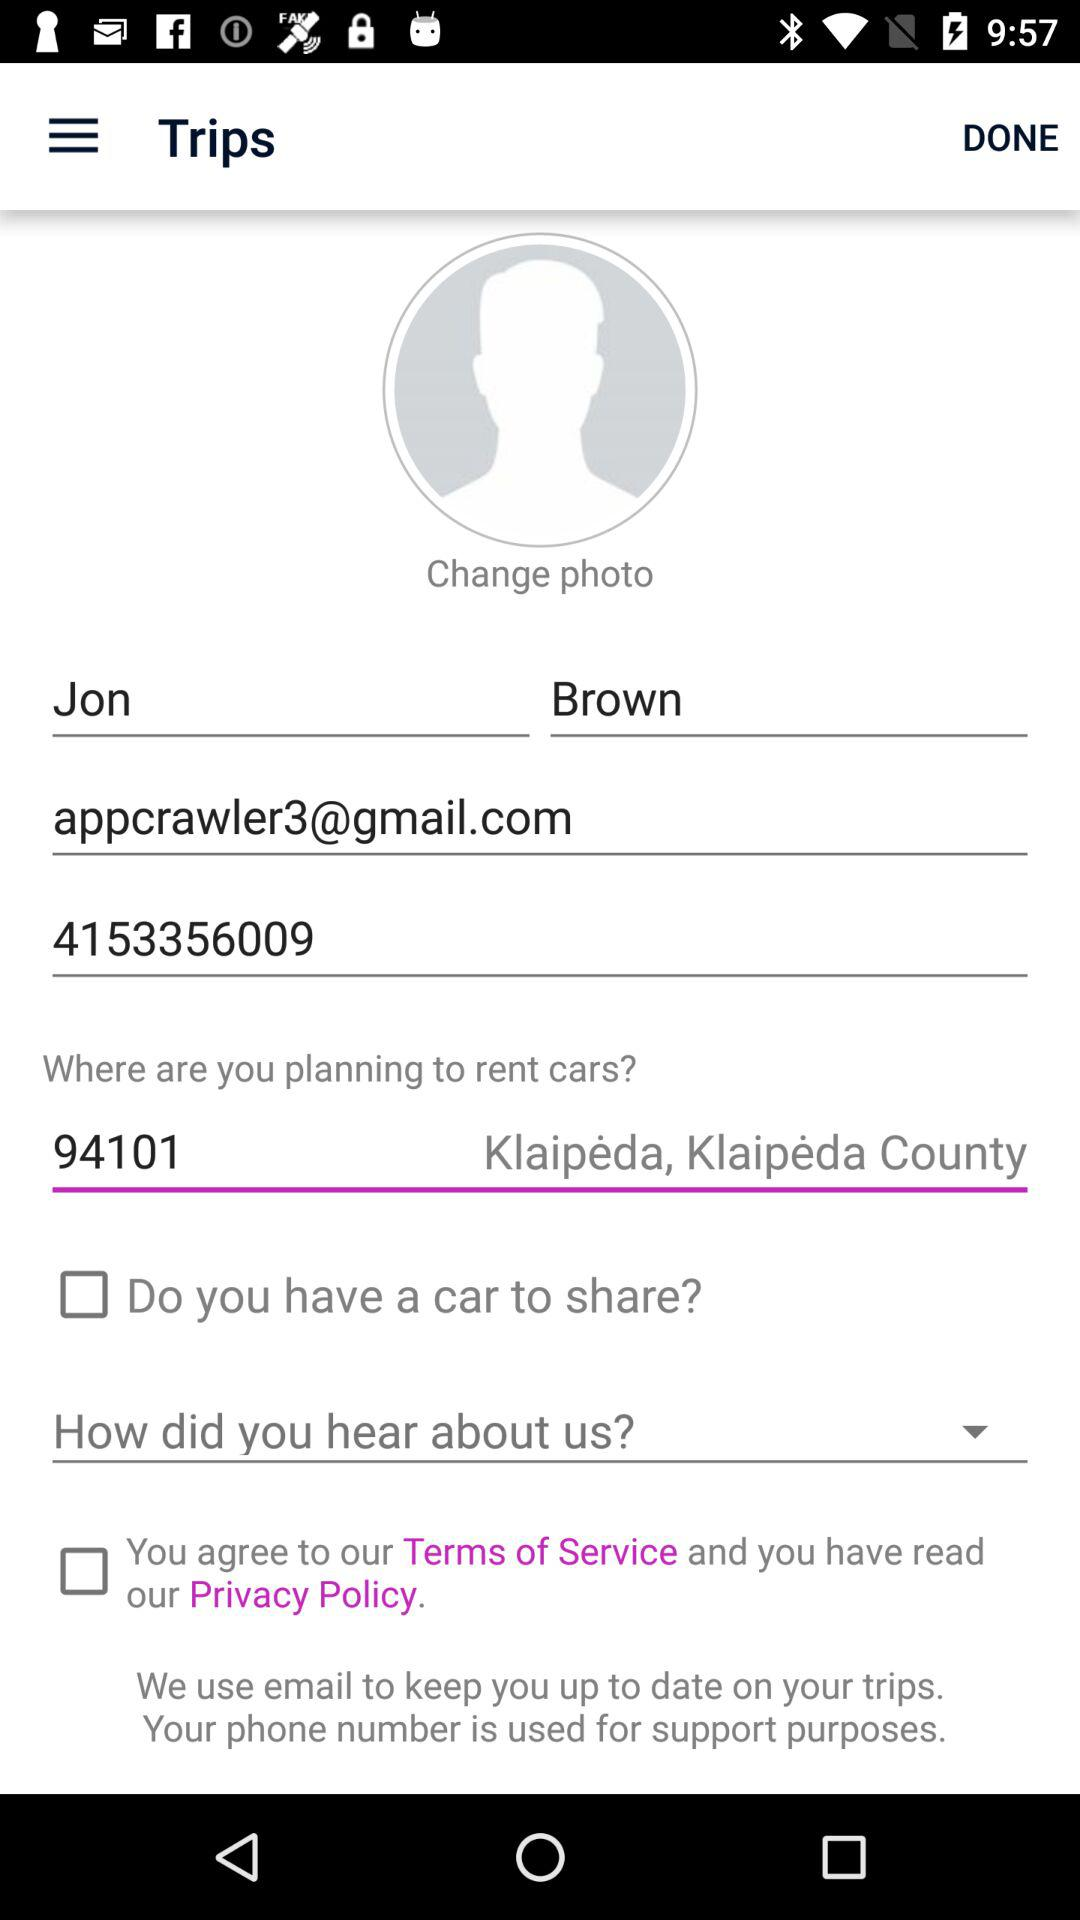What is the status of the option that includes agreement to the “Terms of Service" and reading of the "Privacy Policy"? The status of the option that includes agreement to the "Terms of Service" and reading of the "Privacy Policy" is "off". 